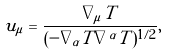Convert formula to latex. <formula><loc_0><loc_0><loc_500><loc_500>u _ { \mu } = \frac { \nabla _ { \mu } T } { ( - \nabla _ { \alpha } T \nabla ^ { \alpha } T ) ^ { 1 / 2 } } ,</formula> 